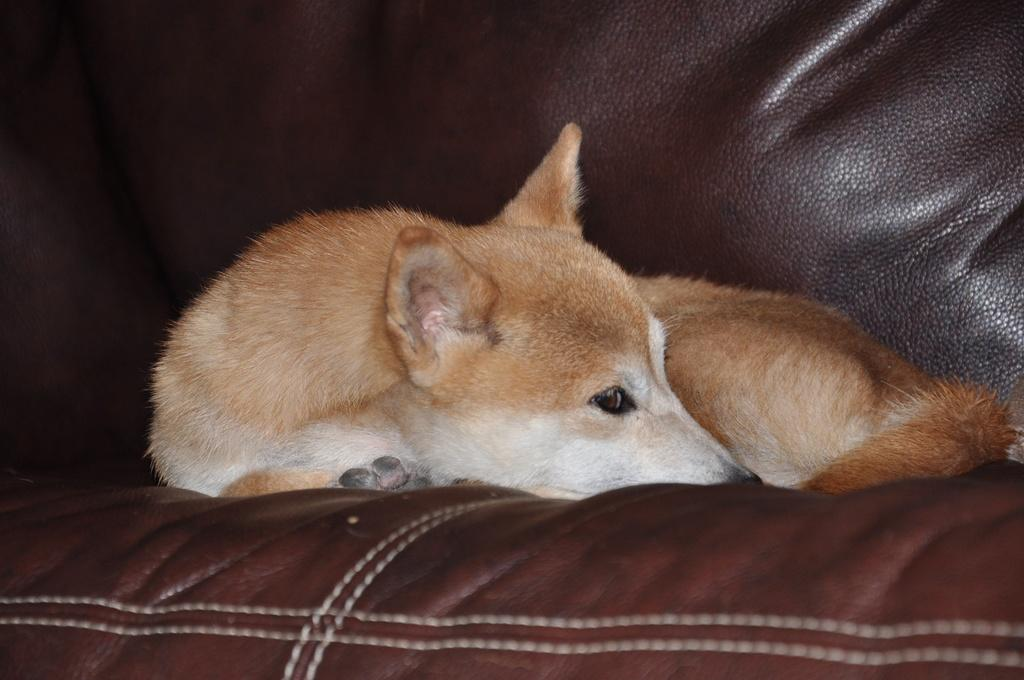What type of animal is present in the image? There is a dog in the image. Where is the dog located? The dog is laying on a couch. What type of patch is the dog sewing onto the couch in the image? There is no patch or sewing activity present in the image; the dog is simply laying on the couch. 